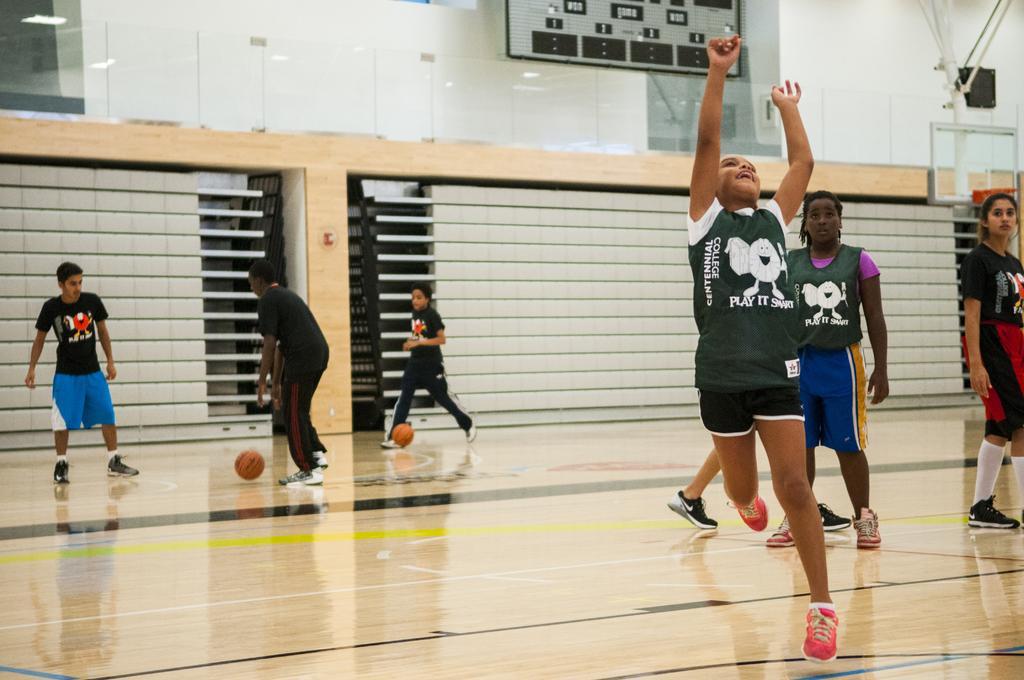Describe this image in one or two sentences. As we can see in the image there are balls, few people here and there and a white color wall. 